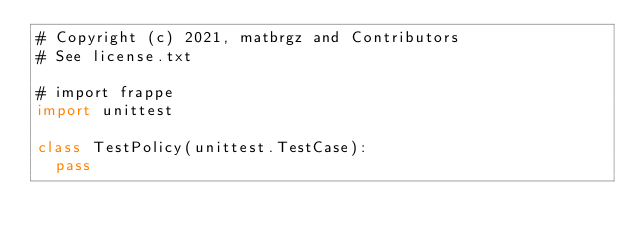<code> <loc_0><loc_0><loc_500><loc_500><_Python_># Copyright (c) 2021, matbrgz and Contributors
# See license.txt

# import frappe
import unittest

class TestPolicy(unittest.TestCase):
	pass
</code> 